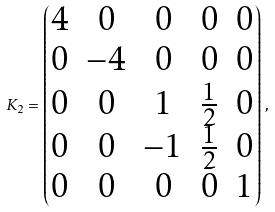<formula> <loc_0><loc_0><loc_500><loc_500>K _ { 2 } = \begin{pmatrix} 4 & 0 & 0 & 0 & 0 \\ 0 & - 4 & 0 & 0 & 0 \\ 0 & 0 & 1 & \frac { 1 } { 2 } & 0 \\ 0 & 0 & - 1 & \frac { 1 } { 2 } & 0 \\ 0 & 0 & 0 & 0 & 1 \end{pmatrix} \, ,</formula> 